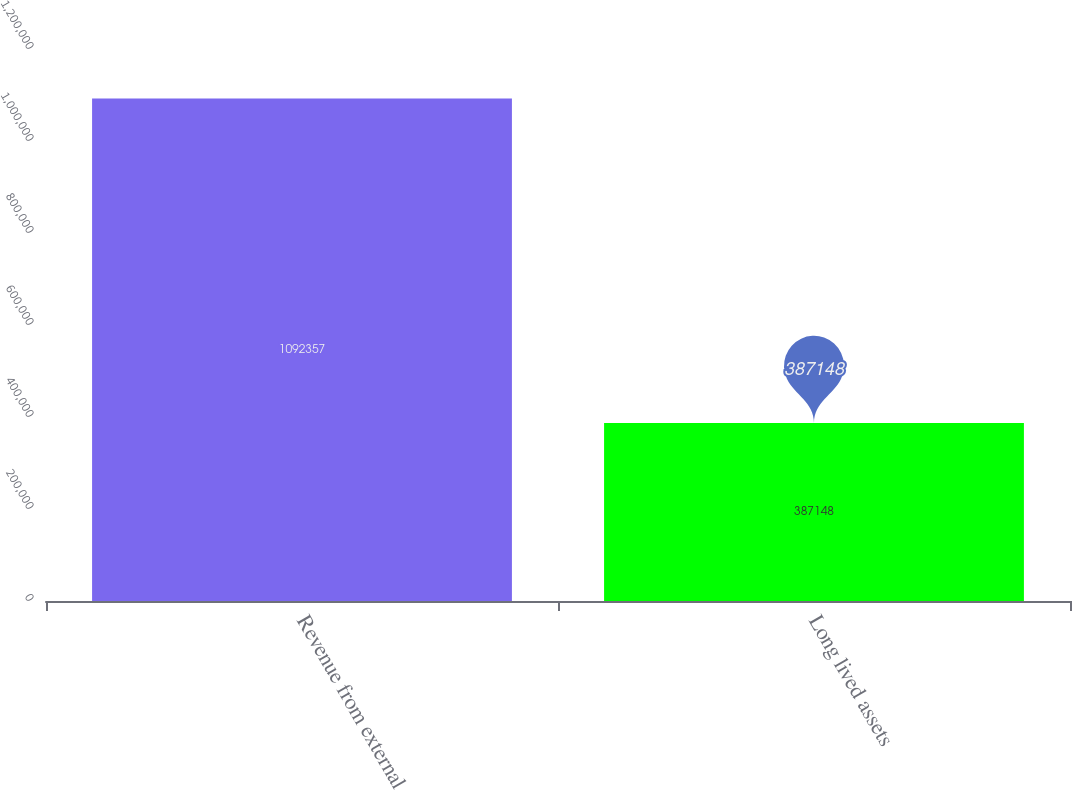<chart> <loc_0><loc_0><loc_500><loc_500><bar_chart><fcel>Revenue from external<fcel>Long lived assets<nl><fcel>1.09236e+06<fcel>387148<nl></chart> 